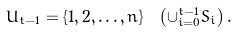<formula> <loc_0><loc_0><loc_500><loc_500>U _ { t - 1 } = \{ 1 , 2 , \dots , n \} \ \left ( \cup _ { i = 0 } ^ { t - 1 } S _ { i } \right ) .</formula> 